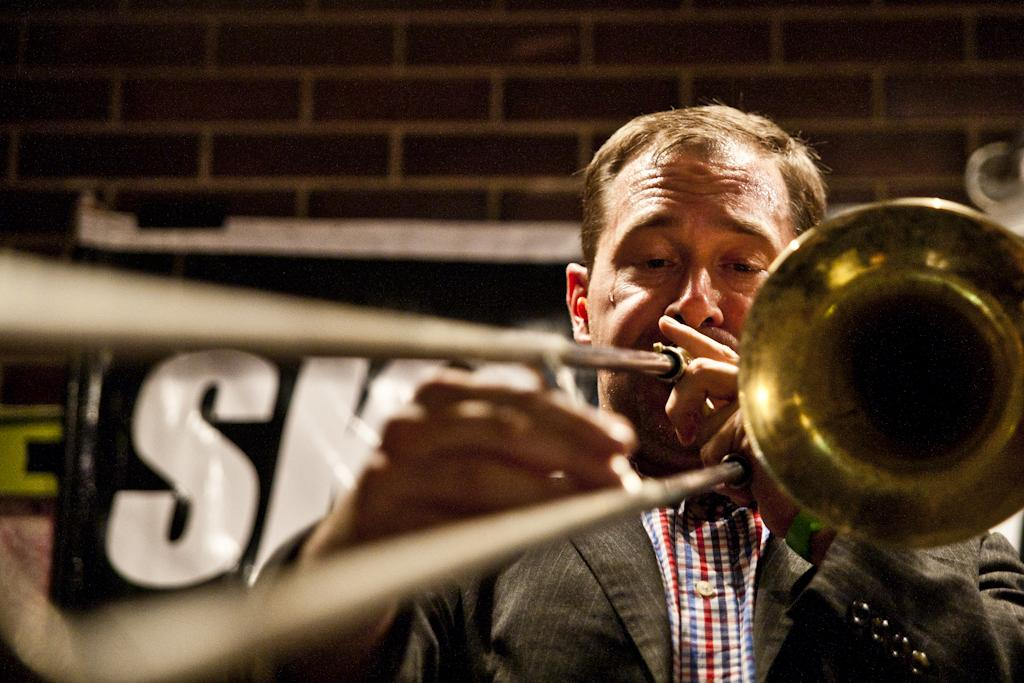What is the man in the image doing? The man is playing a musical instrument. What is the man holding in the image? The man is holding a musical instrument. What can be seen in the background of the image? There is a wall in the background of the image. What is on the wall in the image? There are posters on the wall, and there is text on the posters. What type of leather is visible on the sidewalk in the image? There is no sidewalk or leather present in the image. What is the man's belief about the musical instrument he is playing in the image? The image does not provide any information about the man's beliefs regarding the musical instrument he is playing. 